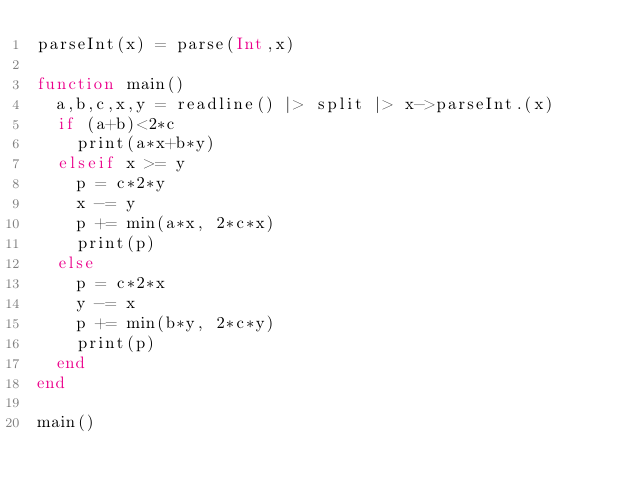Convert code to text. <code><loc_0><loc_0><loc_500><loc_500><_Julia_>parseInt(x) = parse(Int,x)

function main()
	a,b,c,x,y = readline() |> split |> x->parseInt.(x)
	if (a+b)<2*c
		print(a*x+b*y)
	elseif x >= y
		p = c*2*y
		x -= y
		p += min(a*x, 2*c*x)
		print(p)
	else
		p = c*2*x
		y -= x
		p += min(b*y, 2*c*y)
		print(p)
	end
end

main()</code> 